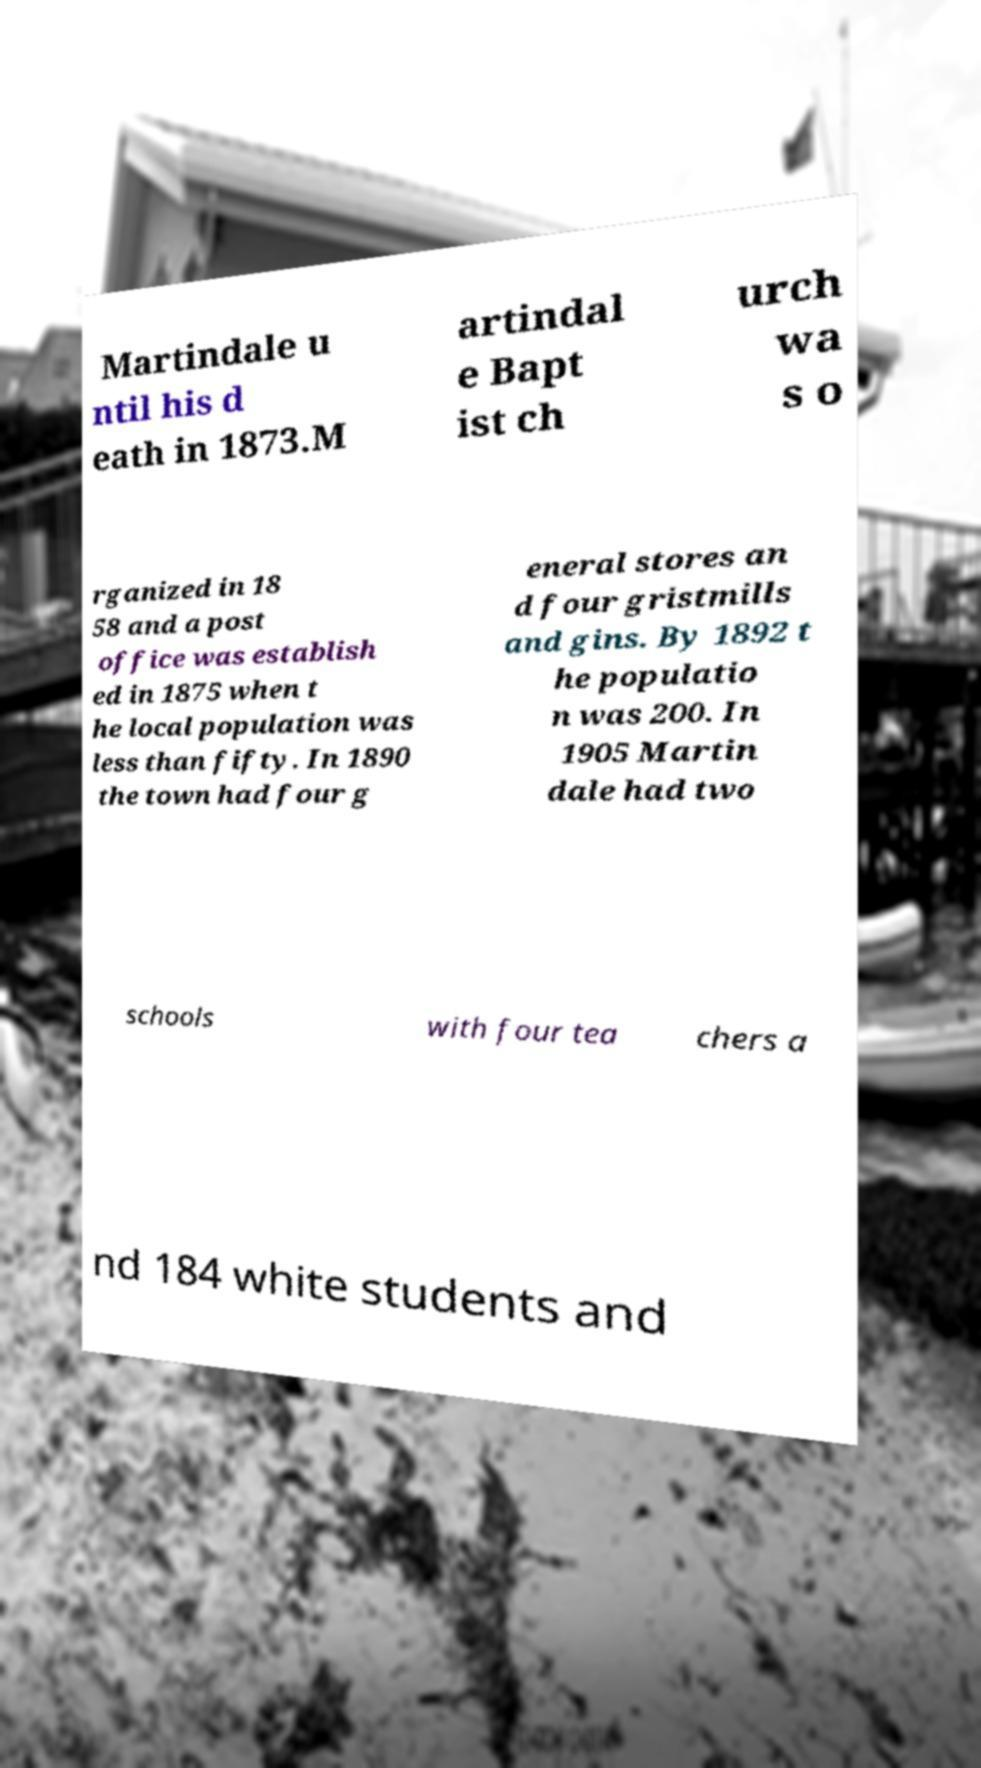I need the written content from this picture converted into text. Can you do that? Martindale u ntil his d eath in 1873.M artindal e Bapt ist ch urch wa s o rganized in 18 58 and a post office was establish ed in 1875 when t he local population was less than fifty. In 1890 the town had four g eneral stores an d four gristmills and gins. By 1892 t he populatio n was 200. In 1905 Martin dale had two schools with four tea chers a nd 184 white students and 